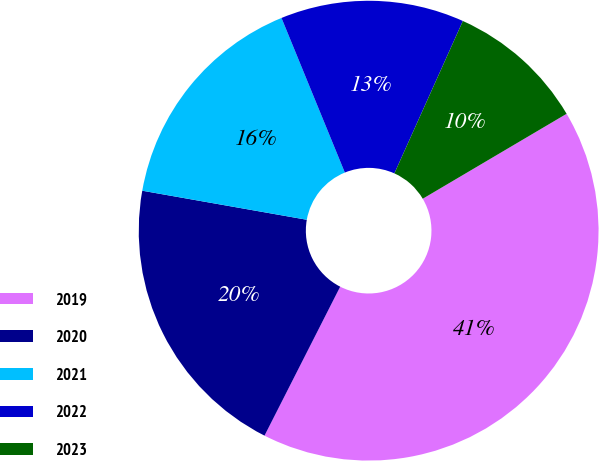Convert chart to OTSL. <chart><loc_0><loc_0><loc_500><loc_500><pie_chart><fcel>2019<fcel>2020<fcel>2021<fcel>2022<fcel>2023<nl><fcel>40.97%<fcel>20.3%<fcel>16.03%<fcel>12.91%<fcel>9.79%<nl></chart> 